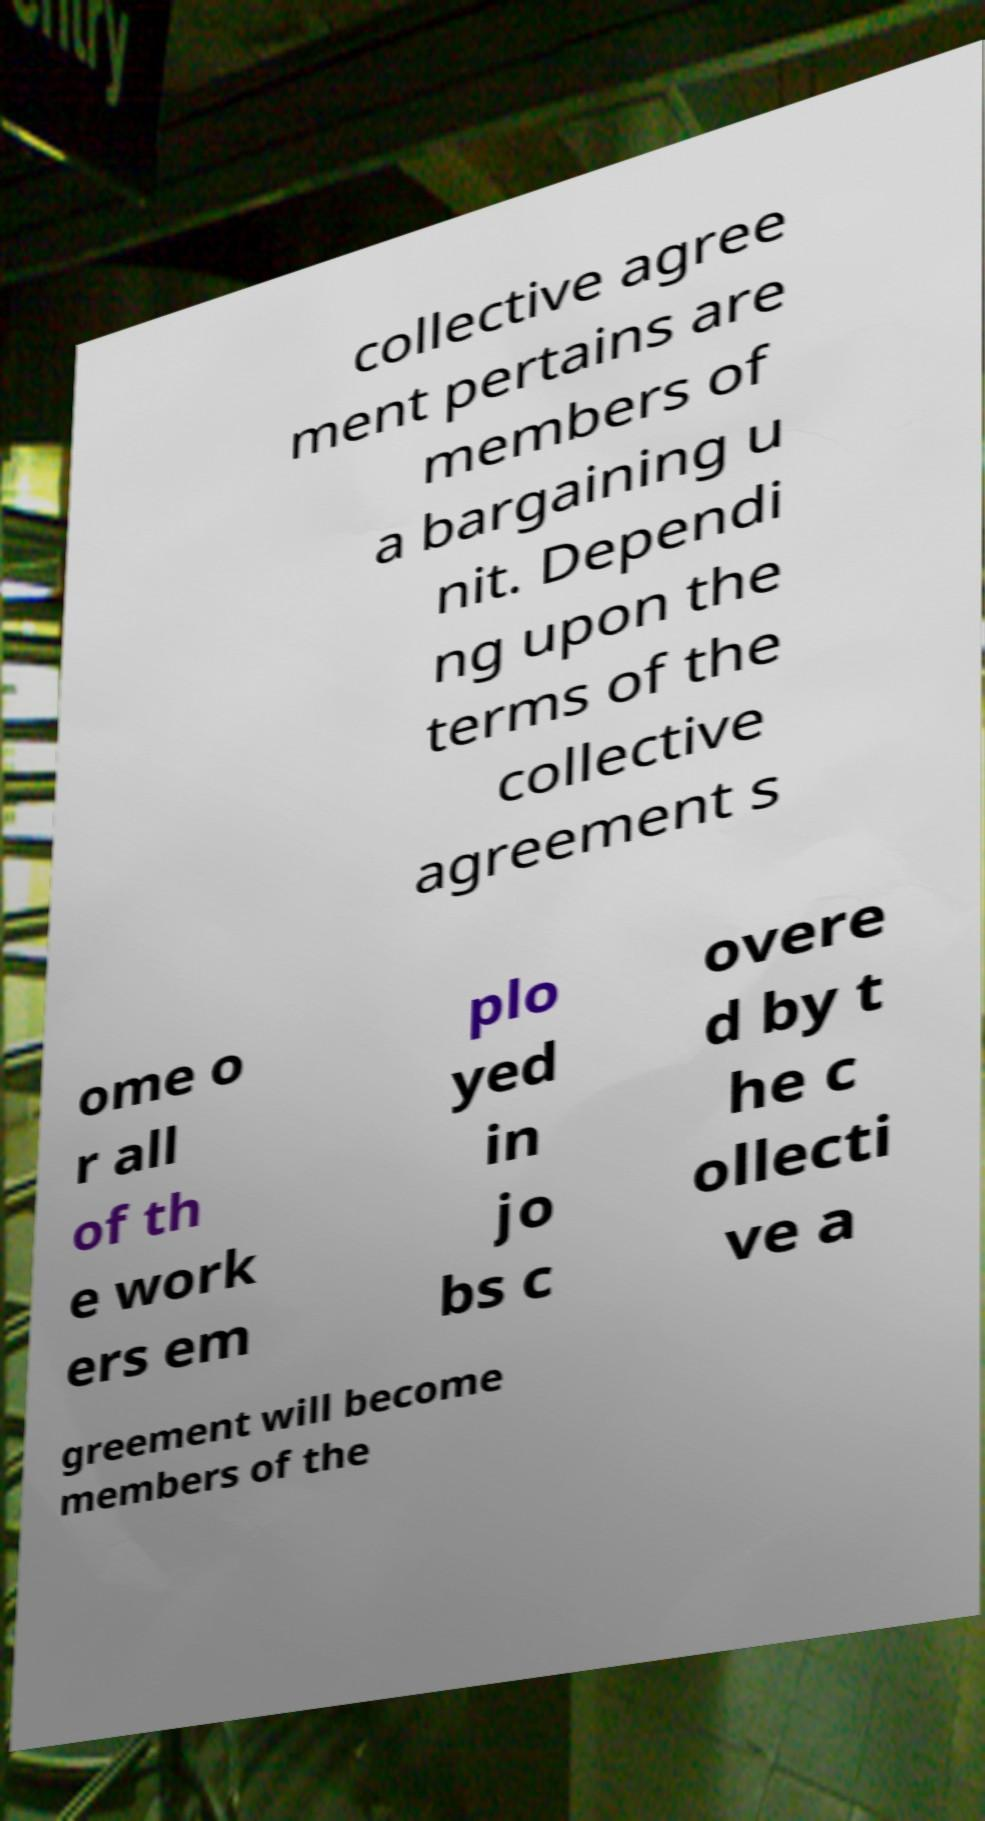Could you assist in decoding the text presented in this image and type it out clearly? collective agree ment pertains are members of a bargaining u nit. Dependi ng upon the terms of the collective agreement s ome o r all of th e work ers em plo yed in jo bs c overe d by t he c ollecti ve a greement will become members of the 